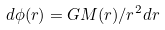Convert formula to latex. <formula><loc_0><loc_0><loc_500><loc_500>d \phi ( r ) = G M ( r ) / r ^ { 2 } d r</formula> 